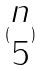<formula> <loc_0><loc_0><loc_500><loc_500>( \begin{matrix} n \\ 5 \end{matrix} )</formula> 